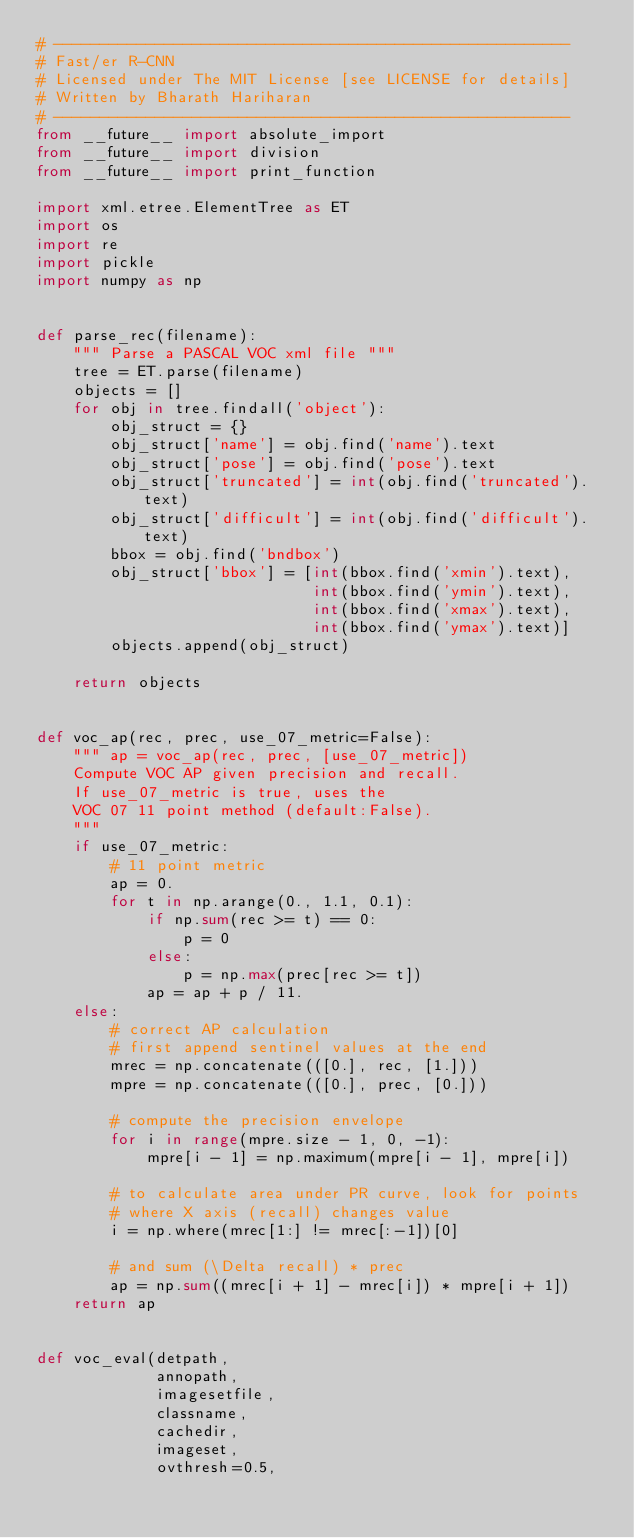Convert code to text. <code><loc_0><loc_0><loc_500><loc_500><_Python_># --------------------------------------------------------
# Fast/er R-CNN
# Licensed under The MIT License [see LICENSE for details]
# Written by Bharath Hariharan
# --------------------------------------------------------
from __future__ import absolute_import
from __future__ import division
from __future__ import print_function

import xml.etree.ElementTree as ET
import os
import re
import pickle
import numpy as np


def parse_rec(filename):
    """ Parse a PASCAL VOC xml file """
    tree = ET.parse(filename)
    objects = []
    for obj in tree.findall('object'):
        obj_struct = {}
        obj_struct['name'] = obj.find('name').text
        obj_struct['pose'] = obj.find('pose').text
        obj_struct['truncated'] = int(obj.find('truncated').text)
        obj_struct['difficult'] = int(obj.find('difficult').text)
        bbox = obj.find('bndbox')
        obj_struct['bbox'] = [int(bbox.find('xmin').text),
                              int(bbox.find('ymin').text),
                              int(bbox.find('xmax').text),
                              int(bbox.find('ymax').text)]
        objects.append(obj_struct)

    return objects


def voc_ap(rec, prec, use_07_metric=False):
    """ ap = voc_ap(rec, prec, [use_07_metric])
    Compute VOC AP given precision and recall.
    If use_07_metric is true, uses the
    VOC 07 11 point method (default:False).
    """
    if use_07_metric:
        # 11 point metric
        ap = 0.
        for t in np.arange(0., 1.1, 0.1):
            if np.sum(rec >= t) == 0:
                p = 0
            else:
                p = np.max(prec[rec >= t])
            ap = ap + p / 11.
    else:
        # correct AP calculation
        # first append sentinel values at the end
        mrec = np.concatenate(([0.], rec, [1.]))
        mpre = np.concatenate(([0.], prec, [0.]))

        # compute the precision envelope
        for i in range(mpre.size - 1, 0, -1):
            mpre[i - 1] = np.maximum(mpre[i - 1], mpre[i])

        # to calculate area under PR curve, look for points
        # where X axis (recall) changes value
        i = np.where(mrec[1:] != mrec[:-1])[0]

        # and sum (\Delta recall) * prec
        ap = np.sum((mrec[i + 1] - mrec[i]) * mpre[i + 1])
    return ap


def voc_eval(detpath,
             annopath,
             imagesetfile,
             classname,
             cachedir,
             imageset,
             ovthresh=0.5,</code> 